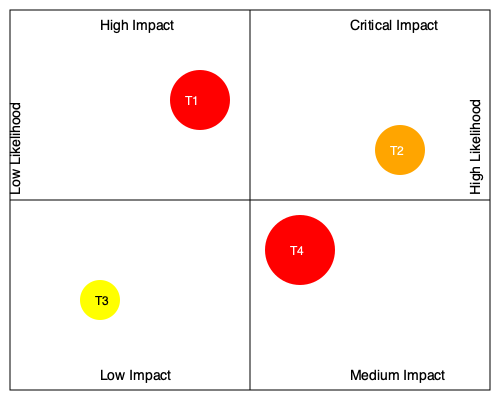Given the threat modeling matrix for a cloud-based database infrastructure, which threat should be prioritized for immediate mitigation based on its impact and likelihood, and what does this threat likely represent in the context of database security? To answer this question, we need to analyze the threat modeling matrix and understand its components:

1. The matrix is divided into four quadrants representing different combinations of impact and likelihood.
2. The x-axis represents likelihood, increasing from left to right.
3. The y-axis represents impact, increasing from bottom to top.
4. There are four threats labeled T1, T2, T3, and T4.

Let's assess each threat:

T1: High impact, moderate-high likelihood (upper-left quadrant)
T2: Critical impact, high likelihood (upper-right quadrant)
T3: Low impact, low likelihood (lower-left quadrant)
T4: Medium-high impact, moderate-high likelihood (near the center, slightly to the right and up)

Based on this analysis, T2 should be prioritized for immediate mitigation because it has both critical impact and high likelihood, making it the most severe threat.

In the context of database security, T2 likely represents a significant threat such as:

1. SQL injection vulnerability: A critical security flaw that allows attackers to manipulate database queries, potentially leading to unauthorized data access, modification, or deletion.
2. Unencrypted data storage: Storing sensitive data without proper encryption in the cloud, making it vulnerable to unauthorized access if the cloud infrastructure is compromised.
3. Weak authentication mechanisms: Insufficient access controls or weak password policies that could allow unauthorized users to gain access to the database.
4. Misconfigured database permissions: Overly permissive access rights that could lead to data breaches or unauthorized data manipulation.

These types of threats have both high impact (potential for significant data loss or breach) and high likelihood (commonly exploited vulnerabilities in cloud-based database systems).
Answer: T2 (SQL injection, unencrypted data, weak authentication, or misconfigured permissions) 